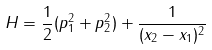Convert formula to latex. <formula><loc_0><loc_0><loc_500><loc_500>H = \frac { 1 } { 2 } ( p _ { 1 } ^ { 2 } + p _ { 2 } ^ { 2 } ) + \frac { 1 } { ( x _ { 2 } - x _ { 1 } ) ^ { 2 } }</formula> 